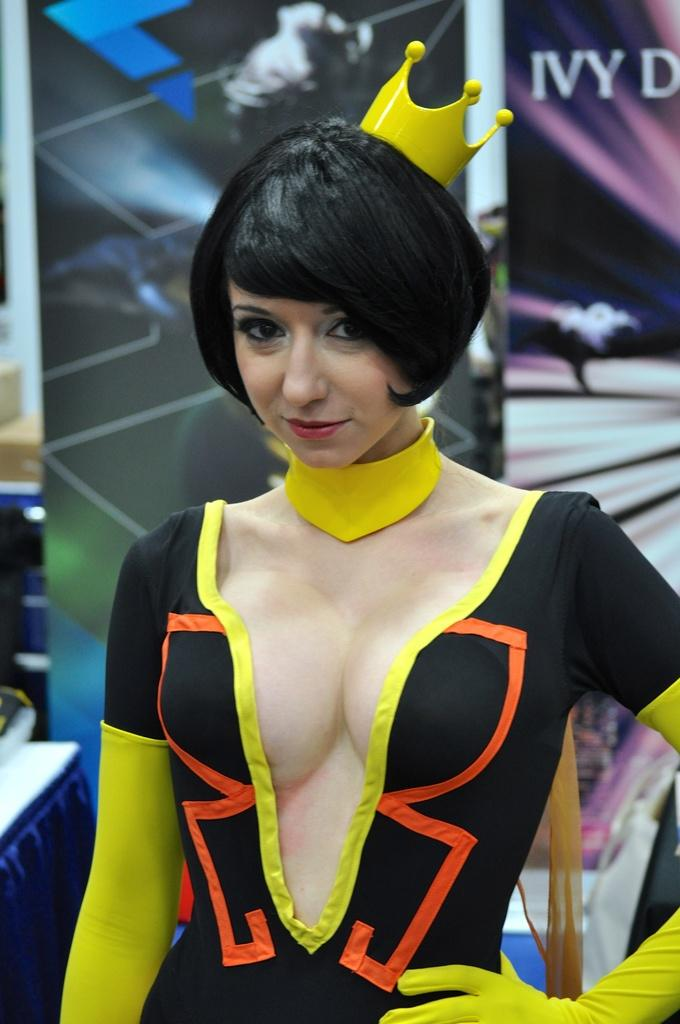<image>
Relay a brief, clear account of the picture shown. A costumed woman stand in front of a banner that partially reads "IVY" 